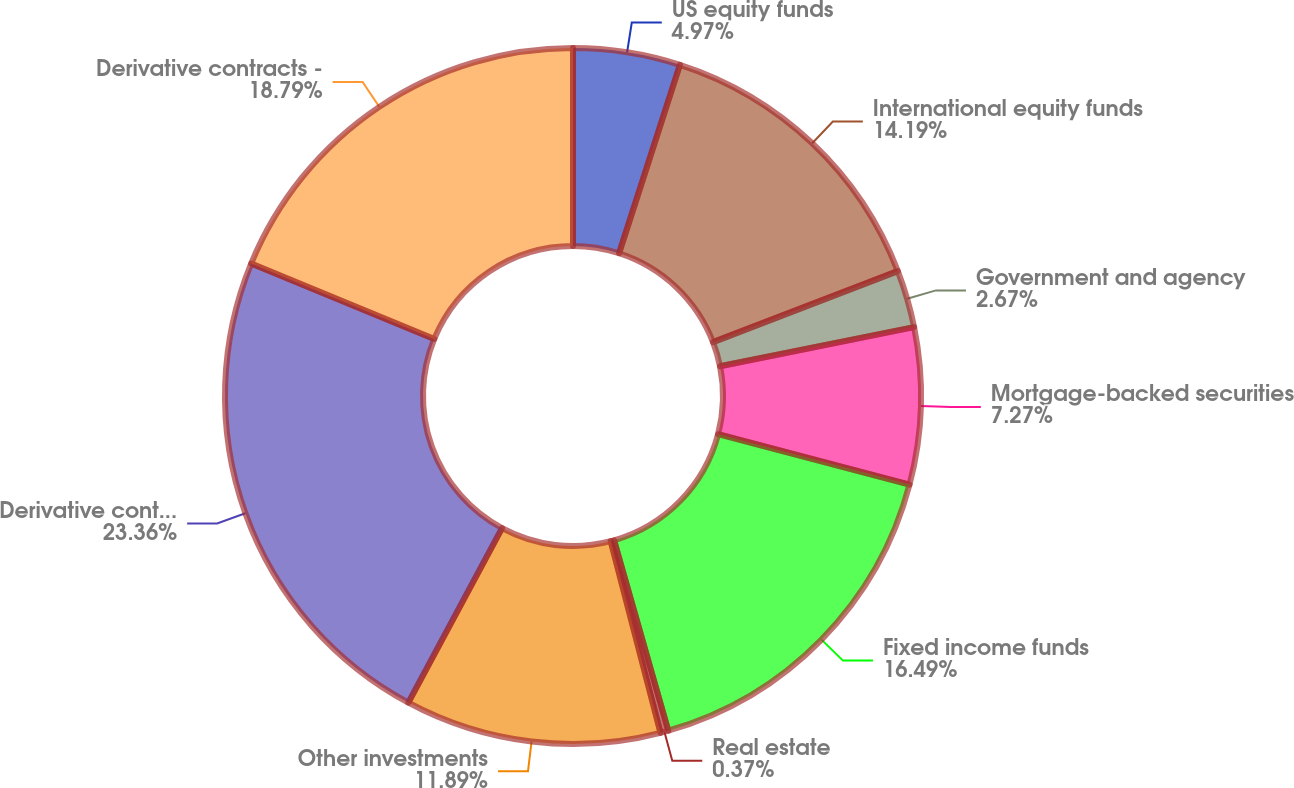Convert chart to OTSL. <chart><loc_0><loc_0><loc_500><loc_500><pie_chart><fcel>US equity funds<fcel>International equity funds<fcel>Government and agency<fcel>Mortgage-backed securities<fcel>Fixed income funds<fcel>Real estate<fcel>Other investments<fcel>Derivative contracts - assets<fcel>Derivative contracts -<nl><fcel>4.97%<fcel>14.19%<fcel>2.67%<fcel>7.27%<fcel>16.49%<fcel>0.37%<fcel>11.89%<fcel>23.37%<fcel>18.79%<nl></chart> 